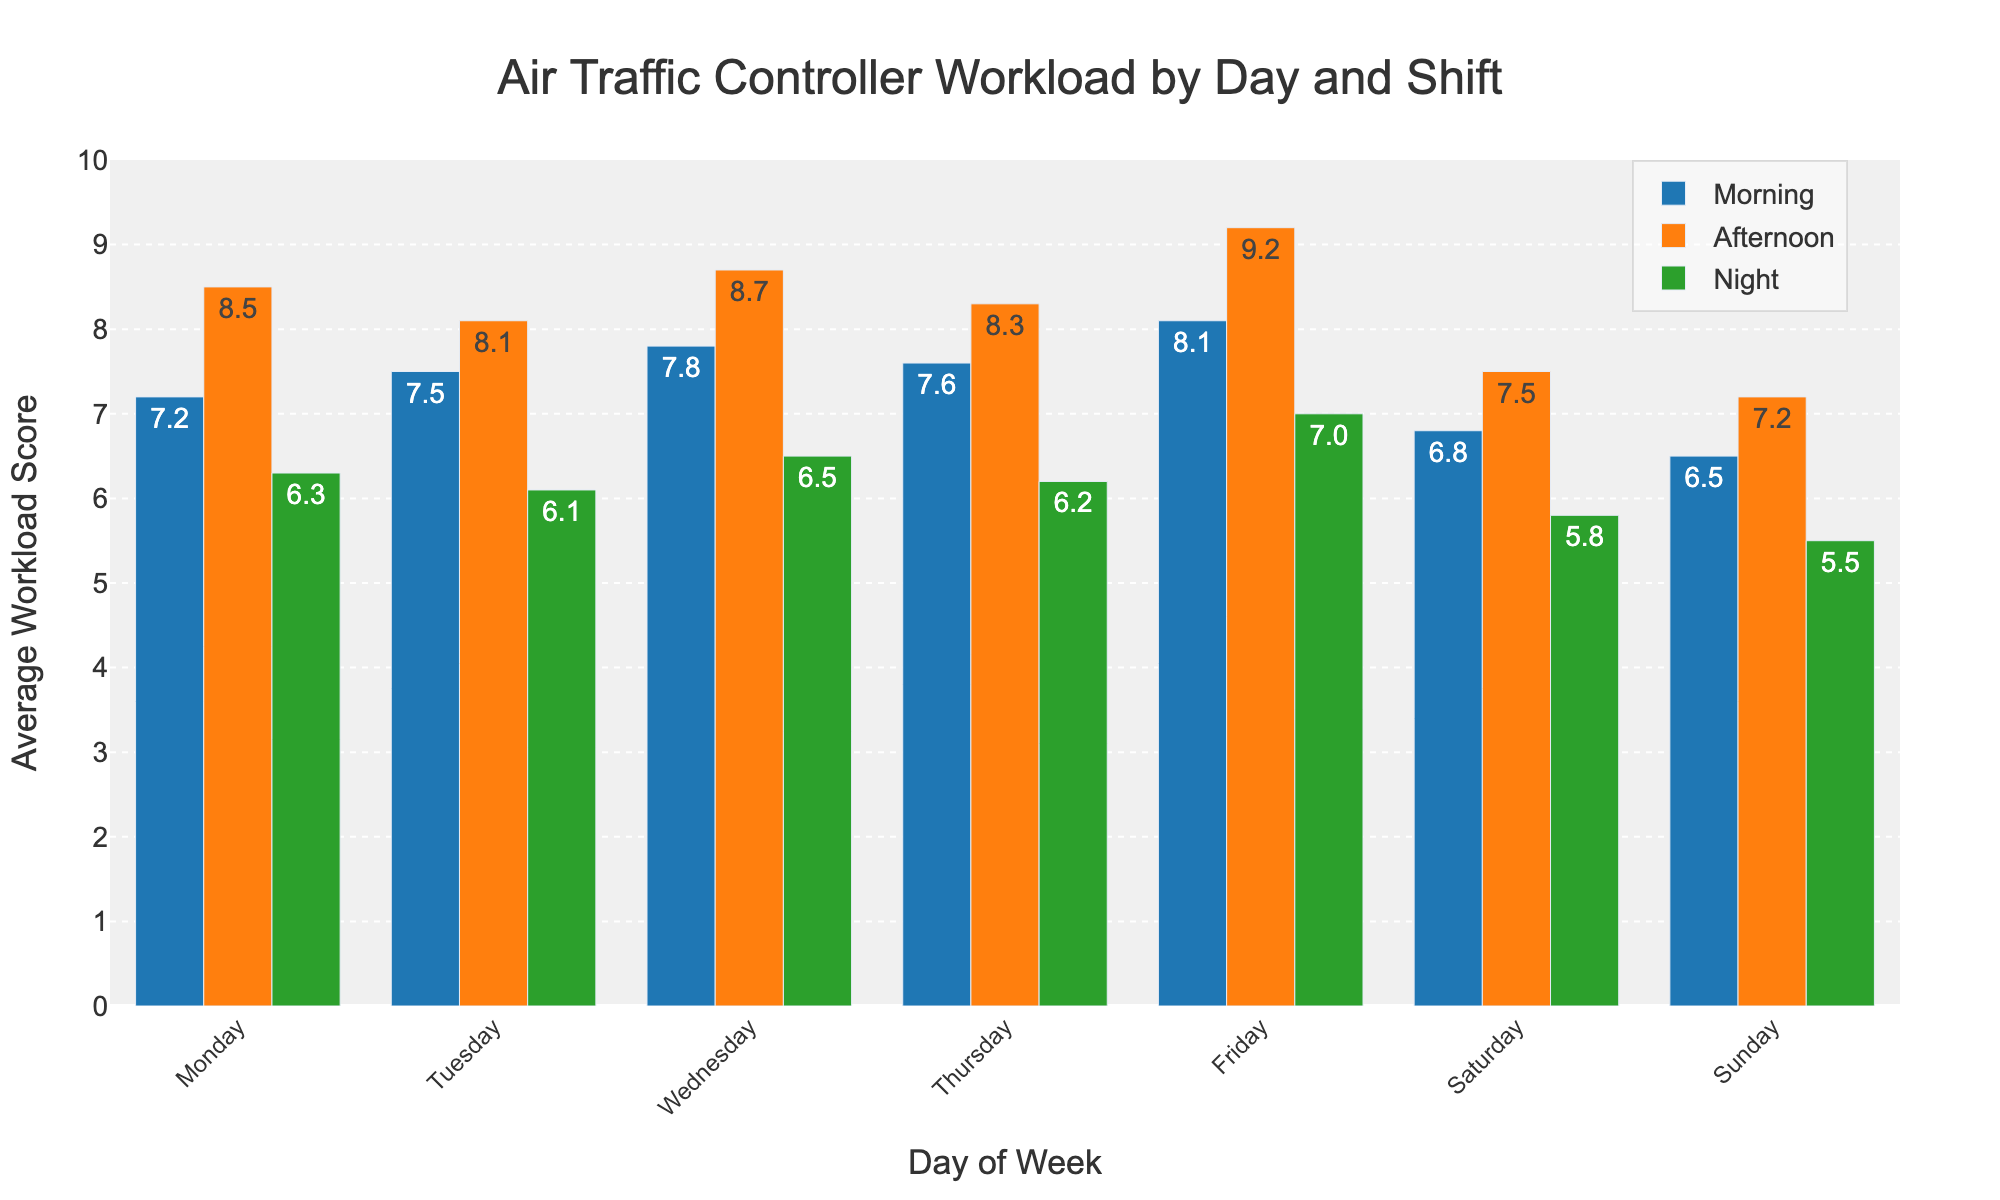Which shift has the highest average workload on Friday? From the figure, find the bars representing Friday for each shift (Morning, Afternoon, Night) and compare their heights. The Afternoon shift has the tallest bar.
Answer: Afternoon What is the difference between the average workload of the Morning shift and the Night shift on Wednesday? Locate the bars for the Morning and Night shifts on Wednesday. Subtract the workload score of the Night shift (6.5) from the Morning shift (7.8).
Answer: 1.3 Which day of the week has the lowest average workload score for the Night shift? Check the height of the Night shift bars for each weekday. The shortest bar is on Sunday.
Answer: Sunday What is the average workload score for all shifts on Friday? Find the workload scores for each shift on Friday (8.1 for Morning, 9.2 for Afternoon, 7.0 for Night). Calculate their average: (8.1 + 9.2 + 7.0) / 3.
Answer: 8.1 Is the average workload higher in the Morning or Afternoon shift on Monday? Compare the heights of the Morning and Afternoon bars on Monday. The Afternoon bar is higher.
Answer: Afternoon What is the total workload score for all shifts on Tuesday? Sum the workload scores of each shift on Tuesday (7.5 for Morning, 8.1 for Afternoon, 6.1 for Night).
Answer: 21.7 On which day is the difference between Morning and Afternoon shift workloads the greatest? Calculate the differences between the Morning and Afternoon shifts for each day and compare. For Friday: 9.2 - 8.1 = 1.1 ; For Wednesday (next highest): 8.7 - 7.8 = 0.9.
Answer: Friday On which day is the Afternoon shift workload the lowest? Identify the shortest bar for the Afternoon shift across all days. The shortest bar is on Sunday.
Answer: Sunday How does the workload of the Night shift on Wednesday compare to that on Thursday? Compare the heights of the Night shift bars on Wednesday and Thursday. Wednesday is slightly higher.
Answer: Higher on Wednesday What is the median workload score for the Morning shifts across the week? List the Morning shift scores (7.2, 7.5, 7.8, 7.6, 8.1, 6.8, 6.5), sort them (6.5, 6.8, 7.2, 7.5, 7.6, 7.8, 8.1), and find the middle value.
Answer: 7.5 